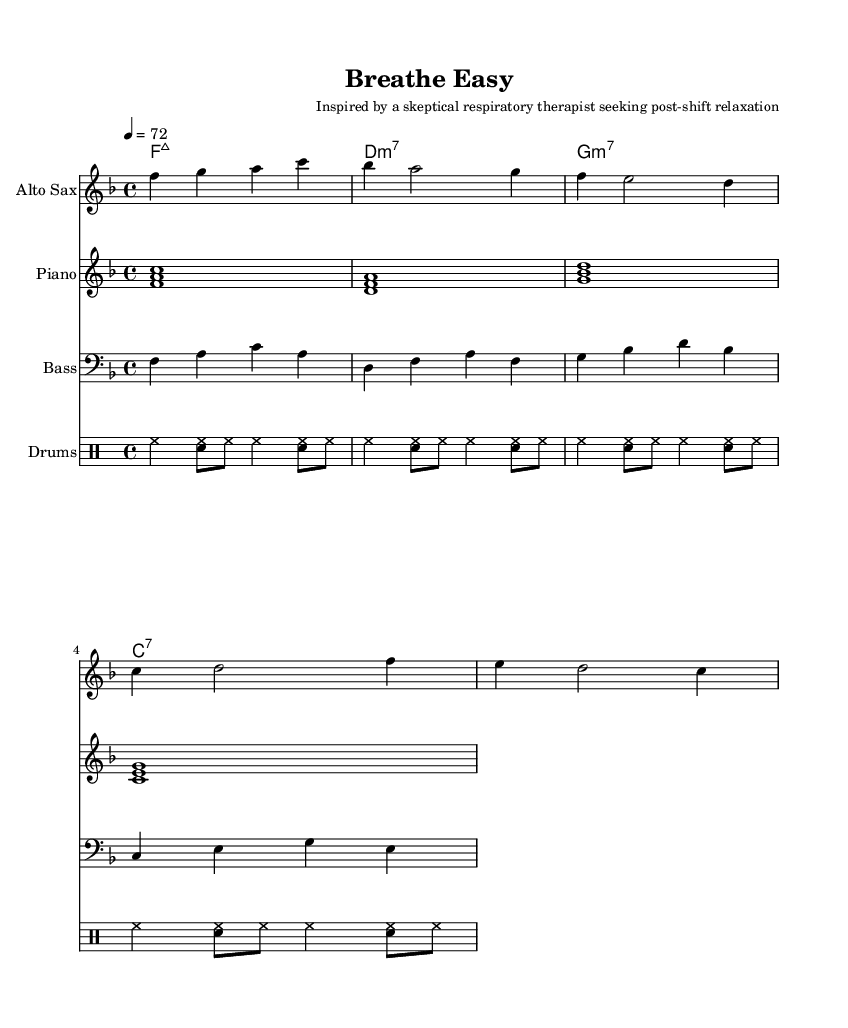What is the key signature of this music? The key signature is F major, which has one flat (B flat). You can determine this by looking at the beginning of the staff and identifying the flat that indicates the key of F major.
Answer: F major What is the time signature of this composition? The time signature is 4/4, which can be found at the beginning of the music. It consists of four beats in each measure and each quarter note receives one beat.
Answer: 4/4 What is the tempo marking for this piece? The tempo marking is “quarter note equals 72,” indicating that the piece should be played at a speed of 72 beats per minute. This is noted next to the tempo indication at the beginning of the score.
Answer: 72 What instruments are featured in this composition? The instruments featured are Alto Sax, Piano, Bass, and Drums, as indicated in the score headers at the beginning of each staff.
Answer: Alto Sax, Piano, Bass, Drums How many measures are in the saxophone part? The saxophone part consists of four measures, which can be counted by looking at the number of vertical lines (bar lines) separating the music notes in the staff.
Answer: 4 What type of chords are used in this piece? The chords used are major 7th and minor 7th chords, which can be identified from the chord names provided in the ChordNames section.
Answer: Major 7th, Minor 7th What style of jazz does this piece represent? This piece represents Smooth Jazz, characterized by its relaxing rhythms and melodic lines, suitable for post-shift relaxation, as suggested by the title and composer’s description.
Answer: Smooth Jazz 